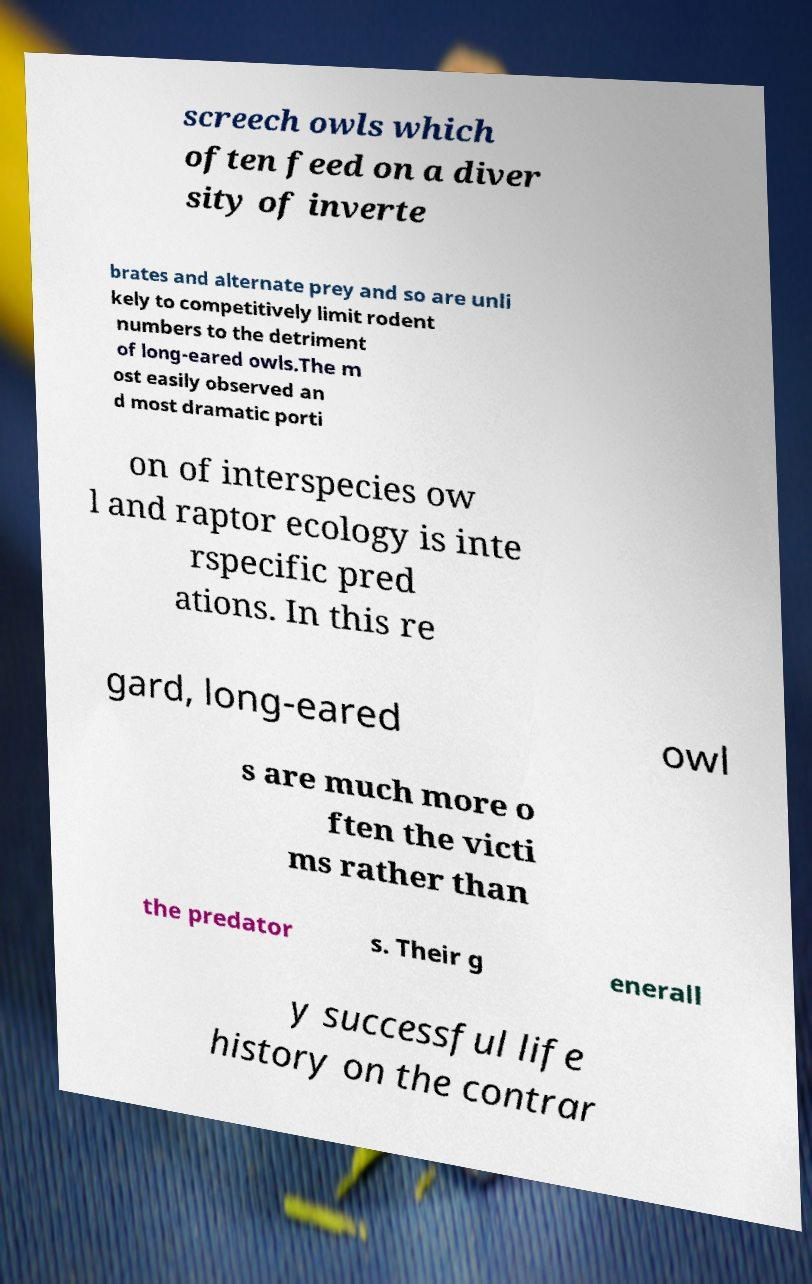There's text embedded in this image that I need extracted. Can you transcribe it verbatim? screech owls which often feed on a diver sity of inverte brates and alternate prey and so are unli kely to competitively limit rodent numbers to the detriment of long-eared owls.The m ost easily observed an d most dramatic porti on of interspecies ow l and raptor ecology is inte rspecific pred ations. In this re gard, long-eared owl s are much more o ften the victi ms rather than the predator s. Their g enerall y successful life history on the contrar 